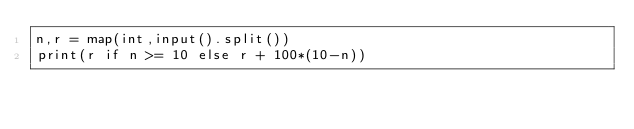Convert code to text. <code><loc_0><loc_0><loc_500><loc_500><_Python_>n,r = map(int,input().split())
print(r if n >= 10 else r + 100*(10-n))</code> 